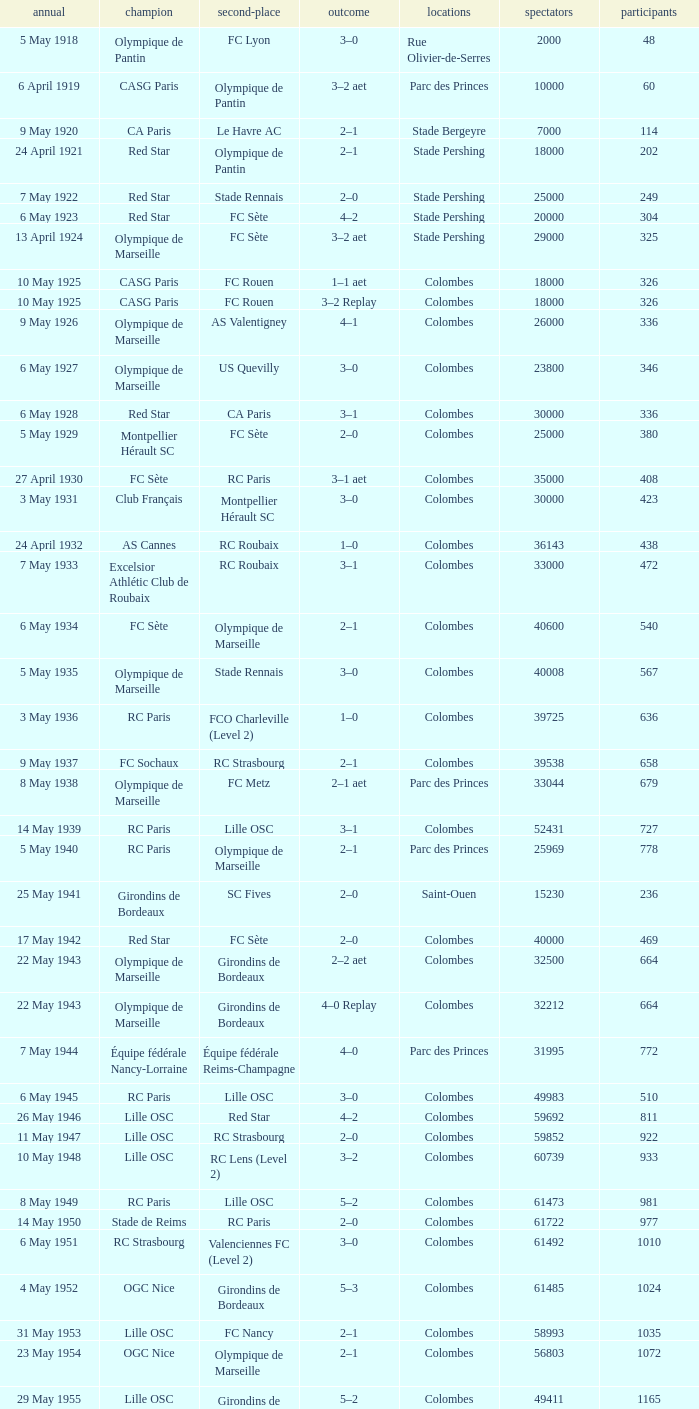How many games had red star as the runner up? 1.0. 